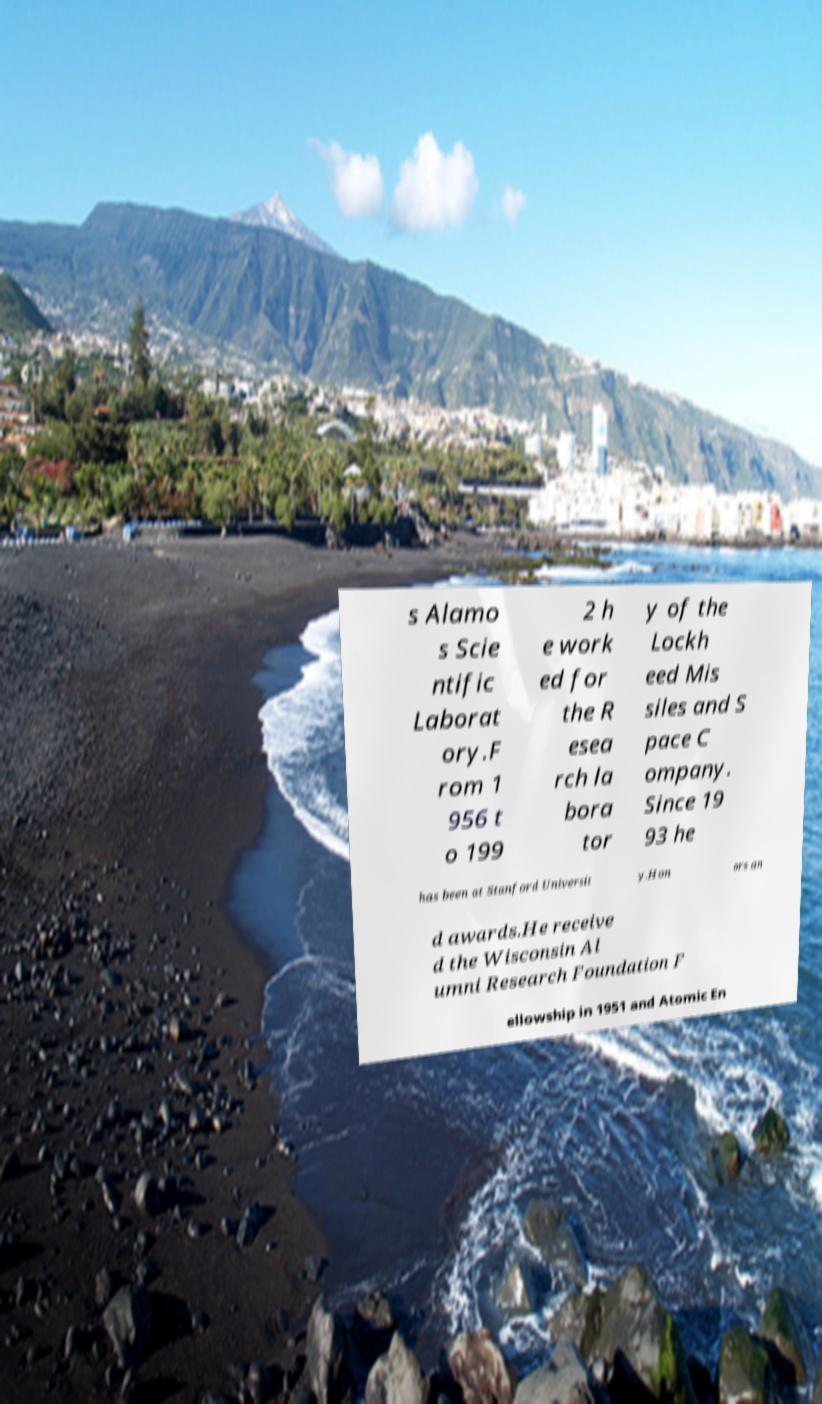What messages or text are displayed in this image? I need them in a readable, typed format. s Alamo s Scie ntific Laborat ory.F rom 1 956 t o 199 2 h e work ed for the R esea rch la bora tor y of the Lockh eed Mis siles and S pace C ompany. Since 19 93 he has been at Stanford Universit y.Hon ors an d awards.He receive d the Wisconsin Al umni Research Foundation F ellowship in 1951 and Atomic En 